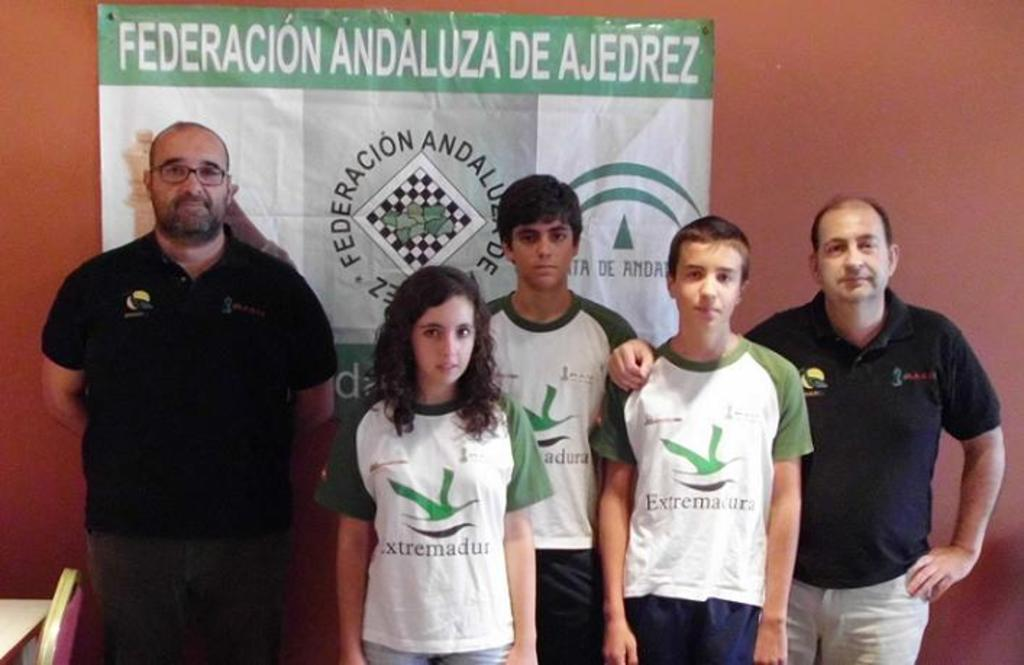<image>
Write a terse but informative summary of the picture. Three children wearing the same gree tops stand between two men beneath a poster bearing the words Federacion Andaluza De Ajedrez 